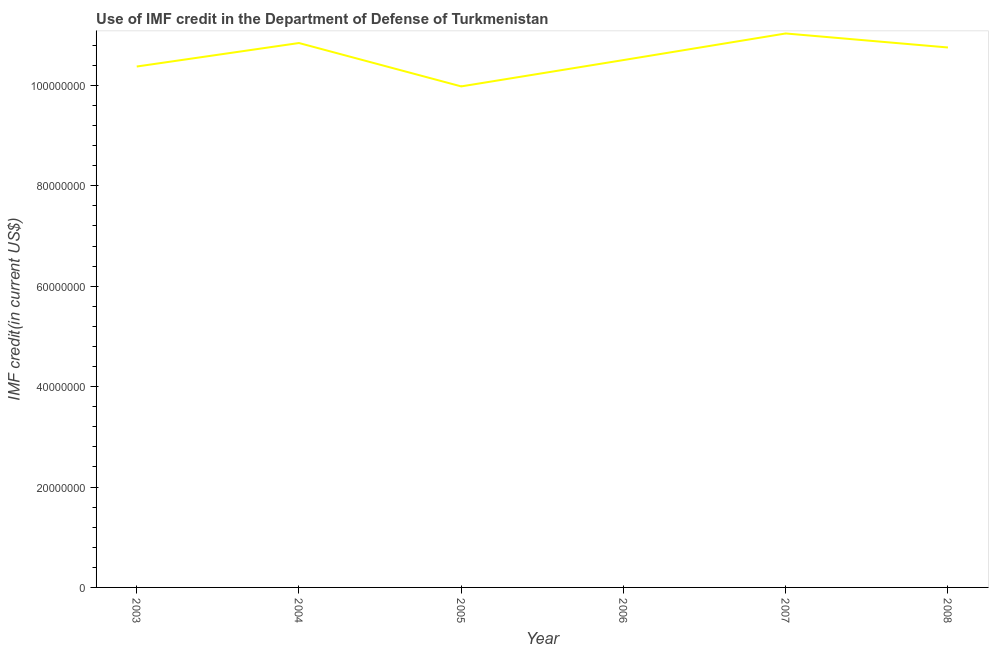What is the use of imf credit in dod in 2008?
Provide a succinct answer. 1.08e+08. Across all years, what is the maximum use of imf credit in dod?
Make the answer very short. 1.10e+08. Across all years, what is the minimum use of imf credit in dod?
Keep it short and to the point. 9.98e+07. In which year was the use of imf credit in dod minimum?
Make the answer very short. 2005. What is the sum of the use of imf credit in dod?
Offer a very short reply. 6.35e+08. What is the difference between the use of imf credit in dod in 2005 and 2008?
Offer a very short reply. -7.75e+06. What is the average use of imf credit in dod per year?
Ensure brevity in your answer.  1.06e+08. What is the median use of imf credit in dod?
Make the answer very short. 1.06e+08. What is the ratio of the use of imf credit in dod in 2006 to that in 2007?
Keep it short and to the point. 0.95. Is the use of imf credit in dod in 2006 less than that in 2007?
Give a very brief answer. Yes. Is the difference between the use of imf credit in dod in 2005 and 2006 greater than the difference between any two years?
Your answer should be very brief. No. What is the difference between the highest and the second highest use of imf credit in dod?
Keep it short and to the point. 1.90e+06. What is the difference between the highest and the lowest use of imf credit in dod?
Your answer should be compact. 1.05e+07. How many years are there in the graph?
Provide a succinct answer. 6. What is the title of the graph?
Your answer should be compact. Use of IMF credit in the Department of Defense of Turkmenistan. What is the label or title of the Y-axis?
Provide a succinct answer. IMF credit(in current US$). What is the IMF credit(in current US$) of 2003?
Your answer should be very brief. 1.04e+08. What is the IMF credit(in current US$) of 2004?
Give a very brief answer. 1.08e+08. What is the IMF credit(in current US$) in 2005?
Provide a short and direct response. 9.98e+07. What is the IMF credit(in current US$) in 2006?
Your response must be concise. 1.05e+08. What is the IMF credit(in current US$) of 2007?
Offer a very short reply. 1.10e+08. What is the IMF credit(in current US$) in 2008?
Your answer should be compact. 1.08e+08. What is the difference between the IMF credit(in current US$) in 2003 and 2004?
Give a very brief answer. -4.68e+06. What is the difference between the IMF credit(in current US$) in 2003 and 2005?
Your answer should be compact. 3.96e+06. What is the difference between the IMF credit(in current US$) in 2003 and 2006?
Ensure brevity in your answer.  -1.29e+06. What is the difference between the IMF credit(in current US$) in 2003 and 2007?
Ensure brevity in your answer.  -6.58e+06. What is the difference between the IMF credit(in current US$) in 2003 and 2008?
Keep it short and to the point. -3.79e+06. What is the difference between the IMF credit(in current US$) in 2004 and 2005?
Your response must be concise. 8.64e+06. What is the difference between the IMF credit(in current US$) in 2004 and 2006?
Keep it short and to the point. 3.39e+06. What is the difference between the IMF credit(in current US$) in 2004 and 2007?
Your answer should be compact. -1.90e+06. What is the difference between the IMF credit(in current US$) in 2004 and 2008?
Provide a short and direct response. 8.89e+05. What is the difference between the IMF credit(in current US$) in 2005 and 2006?
Your response must be concise. -5.24e+06. What is the difference between the IMF credit(in current US$) in 2005 and 2007?
Keep it short and to the point. -1.05e+07. What is the difference between the IMF credit(in current US$) in 2005 and 2008?
Keep it short and to the point. -7.75e+06. What is the difference between the IMF credit(in current US$) in 2006 and 2007?
Your response must be concise. -5.30e+06. What is the difference between the IMF credit(in current US$) in 2006 and 2008?
Offer a very short reply. -2.50e+06. What is the difference between the IMF credit(in current US$) in 2007 and 2008?
Provide a short and direct response. 2.79e+06. What is the ratio of the IMF credit(in current US$) in 2003 to that in 2004?
Give a very brief answer. 0.96. What is the ratio of the IMF credit(in current US$) in 2004 to that in 2005?
Your response must be concise. 1.09. What is the ratio of the IMF credit(in current US$) in 2004 to that in 2006?
Keep it short and to the point. 1.03. What is the ratio of the IMF credit(in current US$) in 2004 to that in 2008?
Your response must be concise. 1.01. What is the ratio of the IMF credit(in current US$) in 2005 to that in 2007?
Your answer should be very brief. 0.9. What is the ratio of the IMF credit(in current US$) in 2005 to that in 2008?
Offer a very short reply. 0.93. What is the ratio of the IMF credit(in current US$) in 2006 to that in 2007?
Your answer should be compact. 0.95. What is the ratio of the IMF credit(in current US$) in 2007 to that in 2008?
Offer a terse response. 1.03. 